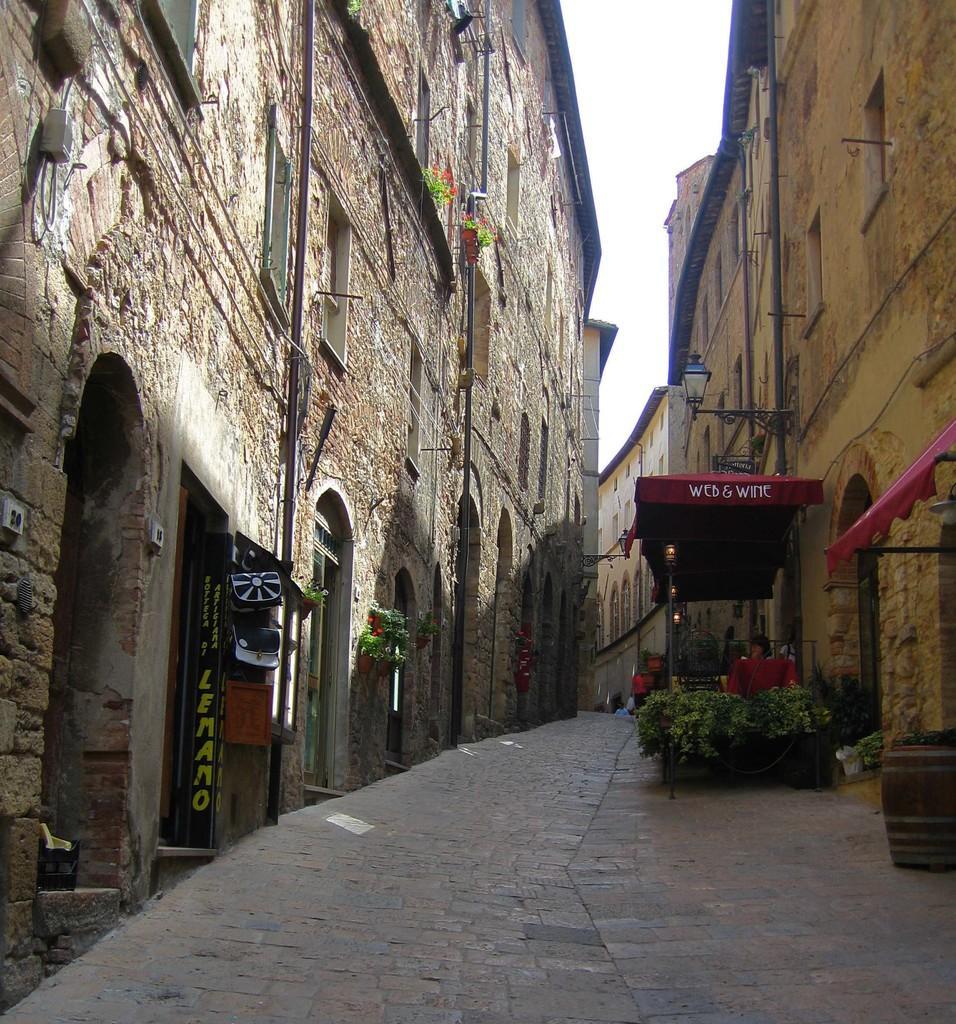In one or two sentences, can you explain what this image depicts? In this image I can see a path and both side of this I can see number of buildings. I can also see few plants, aboard, few lights and a red colour thing. I can also see, on this board and on this something is written. 